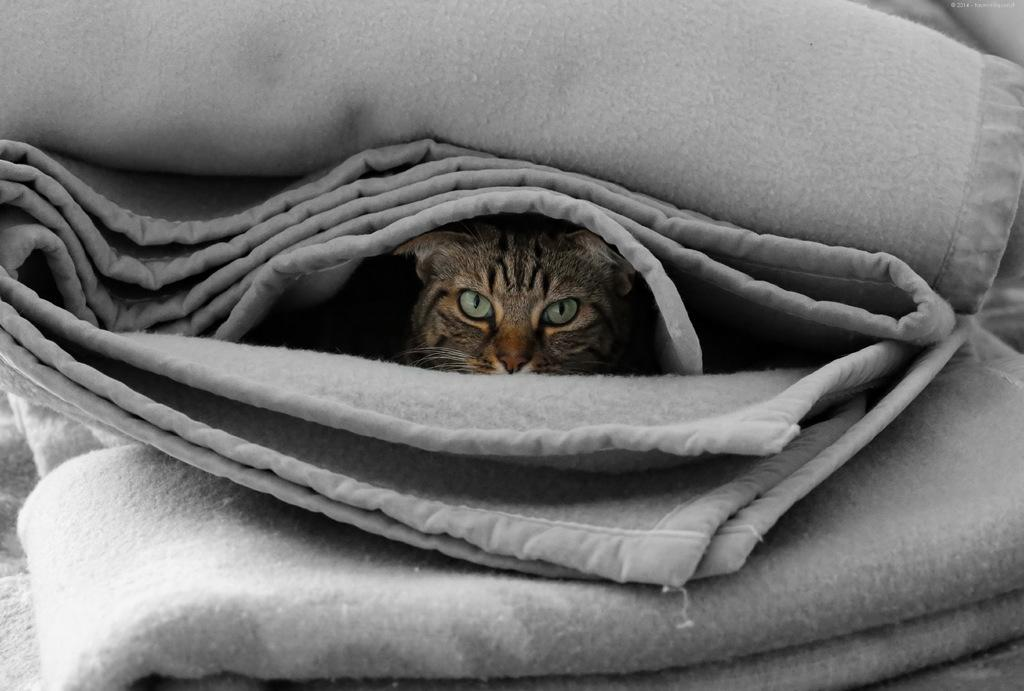What is located in the center of the image? There are blankets in the center of the image. Can you describe the color of the blankets? The blankets are ash-colored. What else can be seen on the blankets? There is a cat visible on the blanket. What type of school can be seen in the background of the image? There is no school visible in the image; it only features blankets and a cat. What is the cat's role in the birth of a newborn in the image? There is no newborn or birth depicted in the image, and the cat's role cannot be determined. 